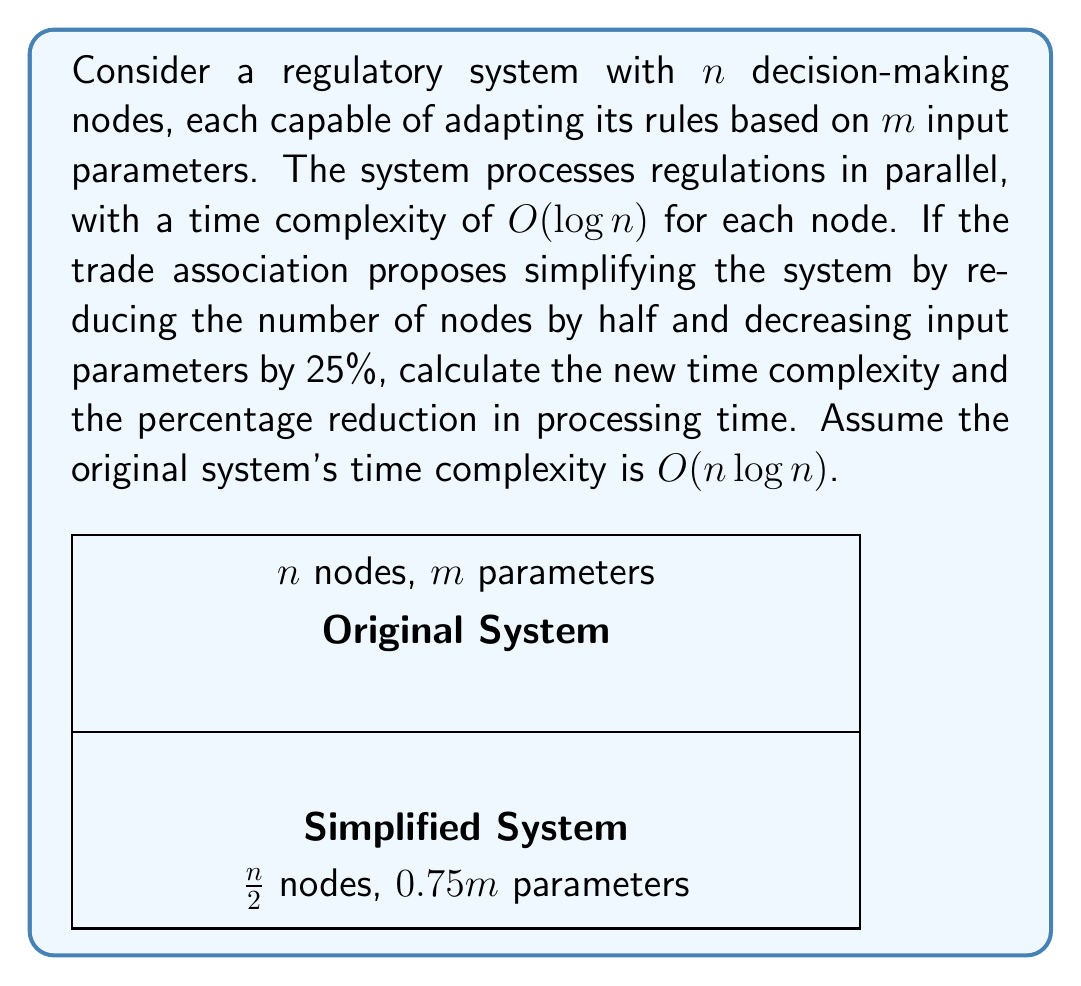What is the answer to this math problem? Let's approach this step-by-step:

1) The original system's time complexity is $O(n \log n)$.

2) In the simplified system:
   - Number of nodes: $\frac{n}{2}$
   - Number of parameters: $0.75m$

3) The new time complexity will be:
   $$O(\frac{n}{2} \log \frac{n}{2})$$

4) Using the logarithm property $\log \frac{a}{b} = \log a - \log b$, we can simplify:
   $$O(\frac{n}{2} (\log n - \log 2))$$

5) Expanding this:
   $$O(\frac{n}{2} \log n - \frac{n}{2} \log 2)$$

6) Simplify:
   $$O(\frac{n}{2} \log n - \frac{n}{2})$$

7) The dominant term here is $\frac{n}{2} \log n$, so the new time complexity is:
   $$O(\frac{n}{2} \log n)$$

8) To calculate the percentage reduction in processing time:
   Original: $O(n \log n)$
   New: $O(\frac{n}{2} \log n)$

   Reduction factor: $\frac{n \log n}{\frac{n}{2} \log n} = 2$

9) Percentage reduction = $(1 - \frac{1}{2}) \times 100\% = 50\%$
Answer: $O(\frac{n}{2} \log n)$; 50% reduction 